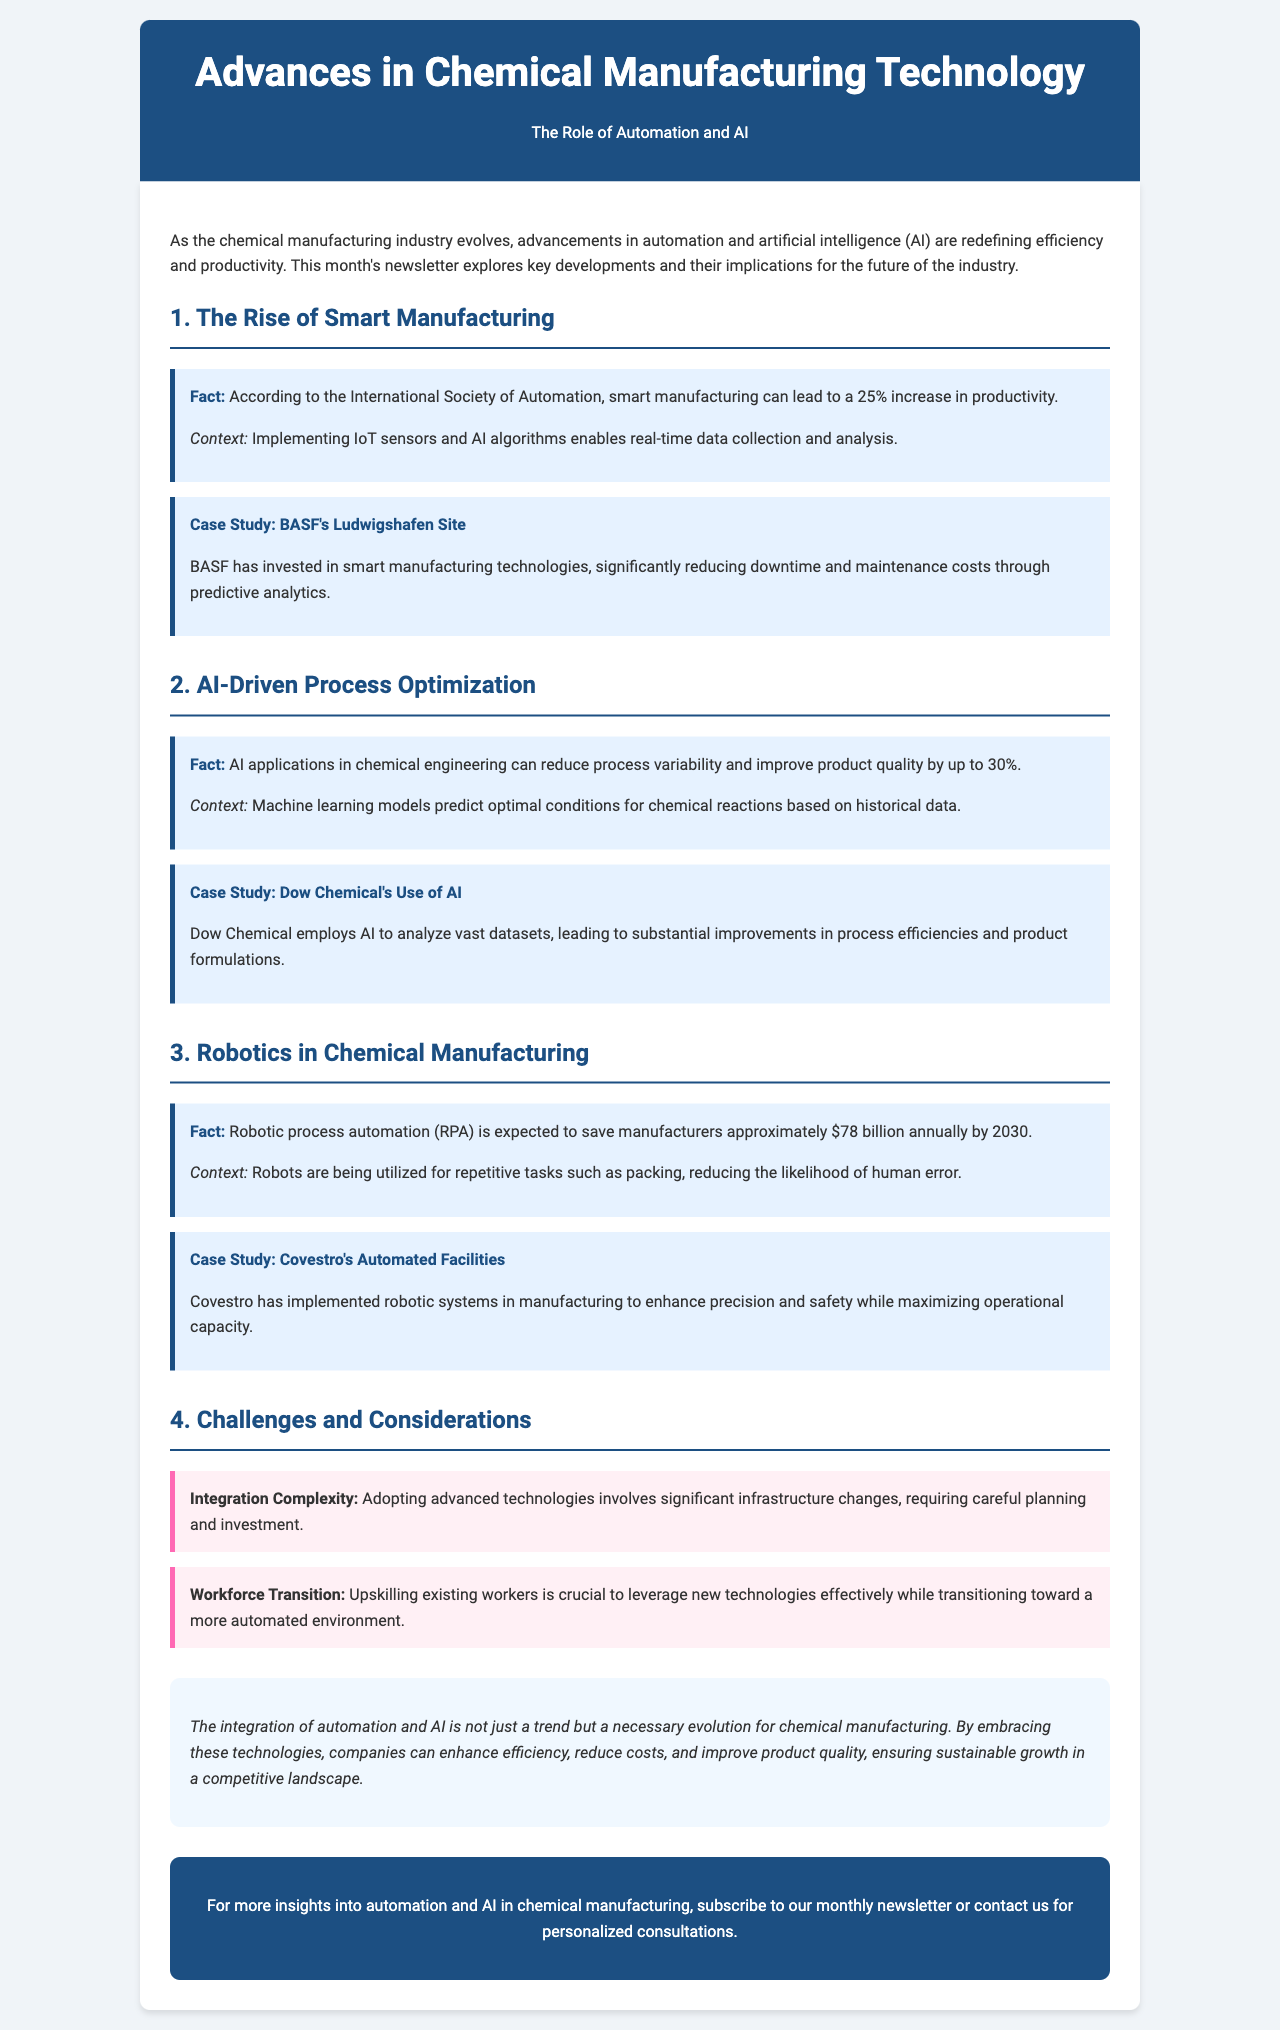What percentage increase in productivity can smart manufacturing lead to? The document states that smart manufacturing can lead to a 25% increase in productivity, according to the International Society of Automation.
Answer: 25% What was BASF able to reduce through predictive analytics? The case study mentions that BASF significantly reduced downtime and maintenance costs through predictive analytics.
Answer: Downtime and maintenance costs By what percentage can AI applications improve product quality? The document indicates that AI applications in chemical engineering can improve product quality by up to 30%.
Answer: 30% What is the expected annual savings from robotic process automation by 2030? The fact mentions that robotic process automation is expected to save manufacturers approximately $78 billion annually by 2030.
Answer: $78 billion What is a challenge mentioned regarding advanced technologies adoption? The document highlights that integration complexity is a challenge when adopting advanced technologies.
Answer: Integration complexity What is a critical factor needed for upskilling existing workers? The document discusses that upskilling existing workers is crucial to leverage new technologies effectively.
Answer: Upskilling existing workers What type of document is this content presented in? The format and structure of the writing represent a newsletter focused on advancements in chemical manufacturing technology.
Answer: Newsletter What role do IoT sensors and AI algorithms play in smart manufacturing? The document explains that implementing IoT sensors and AI algorithms enables real-time data collection and analysis.
Answer: Real-time data collection and analysis 